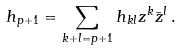<formula> <loc_0><loc_0><loc_500><loc_500>h _ { p + 1 } = \sum _ { k + l = p + 1 } h _ { k l } z ^ { k } \bar { z } ^ { l } \, .</formula> 